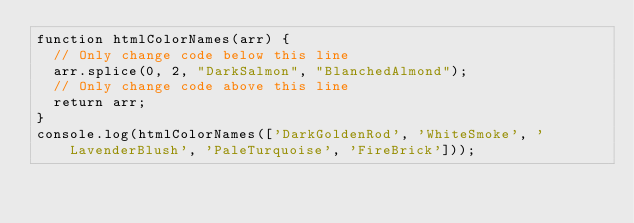<code> <loc_0><loc_0><loc_500><loc_500><_JavaScript_>function htmlColorNames(arr) {  // Only change code below this line  arr.splice(0, 2, "DarkSalmon", "BlanchedAlmond");  // Only change code above this line  return arr;}console.log(htmlColorNames(['DarkGoldenRod', 'WhiteSmoke', 'LavenderBlush', 'PaleTurquoise', 'FireBrick']));</code> 